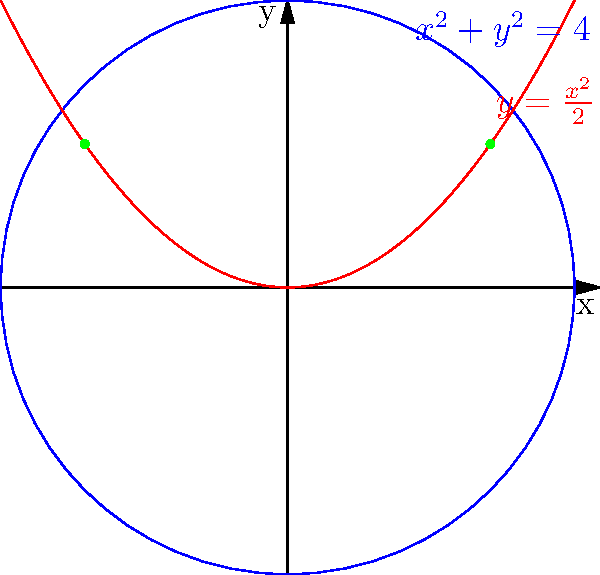In the given coordinate system, a circle with equation $x^2 + y^2 = 4$ intersects with a parabola described by $y = \frac{x^2}{2}$. Determine the x-coordinates of the intersection points. To find the x-coordinates of the intersection points, we need to solve the system of equations:

1) Circle equation: $x^2 + y^2 = 4$
2) Parabola equation: $y = \frac{x^2}{2}$

Step 1: Substitute the parabola equation into the circle equation:
$x^2 + (\frac{x^2}{2})^2 = 4$

Step 2: Simplify:
$x^2 + \frac{x^4}{4} = 4$

Step 3: Multiply both sides by 4:
$4x^2 + x^4 = 16$

Step 4: Rearrange to standard form:
$x^4 + 4x^2 - 16 = 0$

Step 5: Let $u = x^2$, then the equation becomes:
$u^2 + 4u - 16 = 0$

Step 6: Solve this quadratic equation:
$u = \frac{-4 \pm \sqrt{4^2 + 4(16)}}{2} = \frac{-4 \pm \sqrt{80}}{2} = \frac{-4 \pm 4\sqrt{5}}{2}$

Step 7: Simplify:
$u = -2 \pm 2\sqrt{5}$

Step 8: Since $u = x^2$, and we need only the positive solution:
$x^2 = 2(\sqrt{5} - 1)$

Step 9: Take the square root of both sides:
$x = \pm \sqrt{2(\sqrt{5} - 1)}$

Therefore, the x-coordinates of the intersection points are $\pm \sqrt{2(\sqrt{5} - 1)}$.
Answer: $\pm \sqrt{2(\sqrt{5} - 1)}$ 